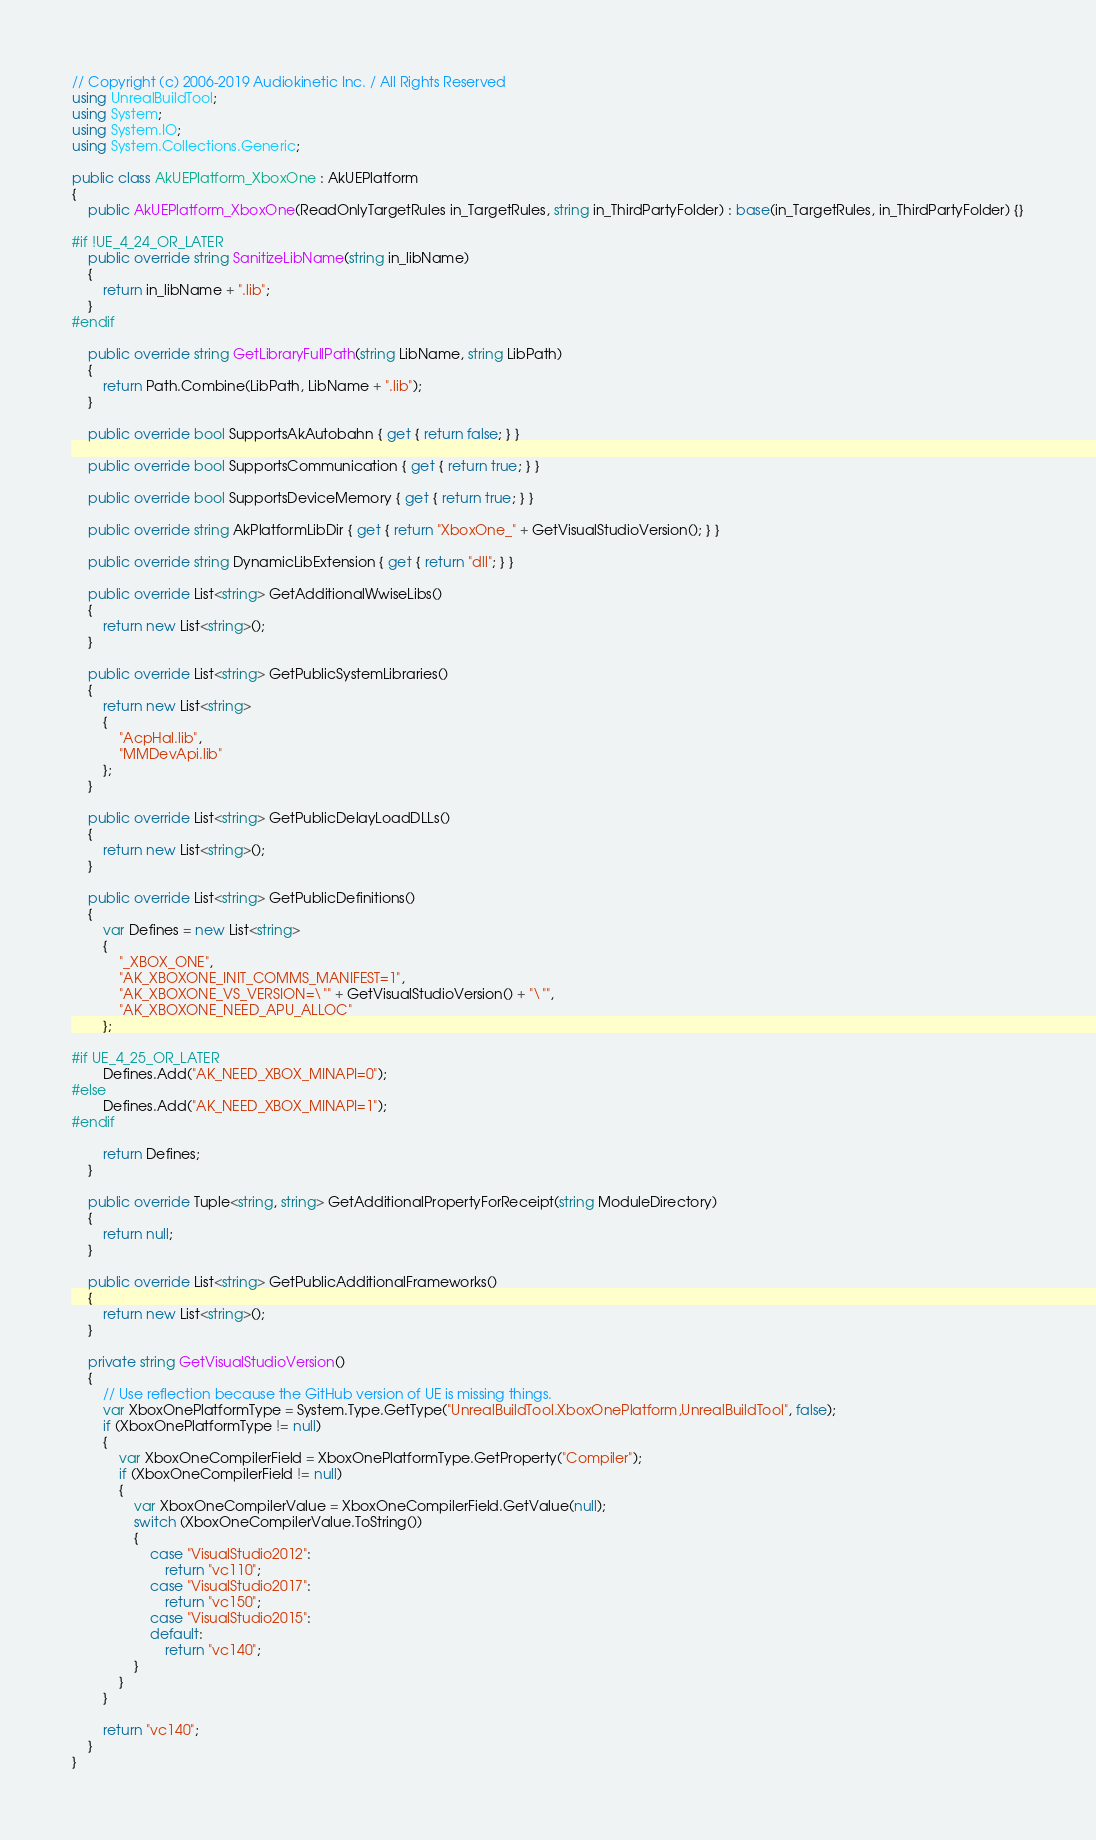Convert code to text. <code><loc_0><loc_0><loc_500><loc_500><_C#_>// Copyright (c) 2006-2019 Audiokinetic Inc. / All Rights Reserved
using UnrealBuildTool;
using System;
using System.IO;
using System.Collections.Generic;

public class AkUEPlatform_XboxOne : AkUEPlatform
{
	public AkUEPlatform_XboxOne(ReadOnlyTargetRules in_TargetRules, string in_ThirdPartyFolder) : base(in_TargetRules, in_ThirdPartyFolder) {}

#if !UE_4_24_OR_LATER
	public override string SanitizeLibName(string in_libName)
	{
		return in_libName + ".lib";
	}
#endif

	public override string GetLibraryFullPath(string LibName, string LibPath)
	{
		return Path.Combine(LibPath, LibName + ".lib");
	}

	public override bool SupportsAkAutobahn { get { return false; } }

	public override bool SupportsCommunication { get { return true; } }

	public override bool SupportsDeviceMemory { get { return true; } }

	public override string AkPlatformLibDir { get { return "XboxOne_" + GetVisualStudioVersion(); } }

	public override string DynamicLibExtension { get { return "dll"; } }

	public override List<string> GetAdditionalWwiseLibs()
	{
		return new List<string>();
	}
	
	public override List<string> GetPublicSystemLibraries()
	{
		return new List<string>
		{
			"AcpHal.lib",
			"MMDevApi.lib"
		};
	}

	public override List<string> GetPublicDelayLoadDLLs()
	{
		return new List<string>();
	}

	public override List<string> GetPublicDefinitions()
	{
		var Defines = new List<string>
		{
			"_XBOX_ONE",
			"AK_XBOXONE_INIT_COMMS_MANIFEST=1",
			"AK_XBOXONE_VS_VERSION=\"" + GetVisualStudioVersion() + "\"",
			"AK_XBOXONE_NEED_APU_ALLOC"
		};
        
#if UE_4_25_OR_LATER
        Defines.Add("AK_NEED_XBOX_MINAPI=0");
#else
        Defines.Add("AK_NEED_XBOX_MINAPI=1");
#endif

		return Defines;
	}

	public override Tuple<string, string> GetAdditionalPropertyForReceipt(string ModuleDirectory)
	{
		return null;
	}

	public override List<string> GetPublicAdditionalFrameworks()
	{
		return new List<string>();
	}

	private string GetVisualStudioVersion()
	{
		// Use reflection because the GitHub version of UE is missing things.
		var XboxOnePlatformType = System.Type.GetType("UnrealBuildTool.XboxOnePlatform,UnrealBuildTool", false);
		if (XboxOnePlatformType != null)
		{
			var XboxOneCompilerField = XboxOnePlatformType.GetProperty("Compiler");
			if (XboxOneCompilerField != null)
			{
				var XboxOneCompilerValue = XboxOneCompilerField.GetValue(null);
				switch (XboxOneCompilerValue.ToString())
				{
					case "VisualStudio2012":
						return "vc110";
					case "VisualStudio2017":
						return "vc150";
					case "VisualStudio2015":
					default:
						return "vc140";
				}
			}
		}

		return "vc140";
	}
}
</code> 